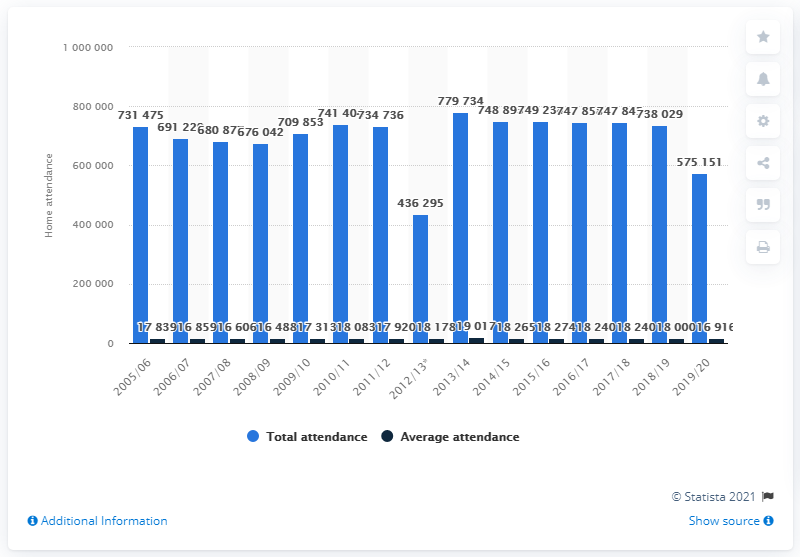Highlight a few significant elements in this photo. The Los Angeles Kings franchise in the NHL last played in the 2005/2006 season. 